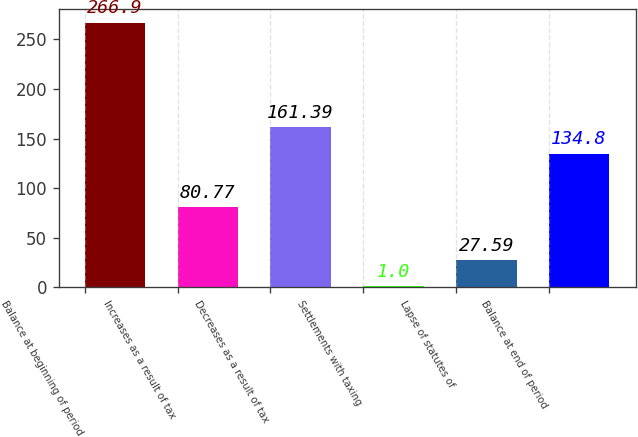<chart> <loc_0><loc_0><loc_500><loc_500><bar_chart><fcel>Balance at beginning of period<fcel>Increases as a result of tax<fcel>Decreases as a result of tax<fcel>Settlements with taxing<fcel>Lapse of statutes of<fcel>Balance at end of period<nl><fcel>266.9<fcel>80.77<fcel>161.39<fcel>1<fcel>27.59<fcel>134.8<nl></chart> 